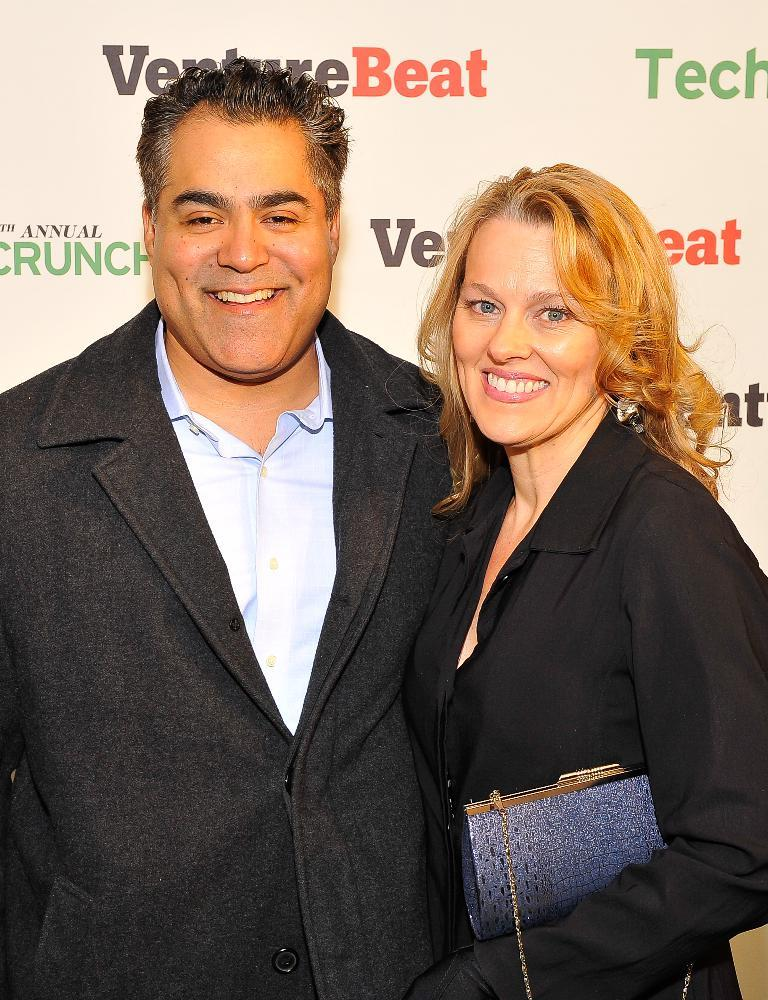How many people are in the image? There are two persons in the image. What are the persons doing in the image? The persons are standing in the image. What is the facial expression of the persons? The persons are smiling in the image. What can be seen behind the persons? There is a banner visible behind the persons. Can you tell me how many pieces of fruit are on the canvas in the image? There is no canvas or fruit present in the image; it features two persons standing and smiling with a banner visible behind them. 